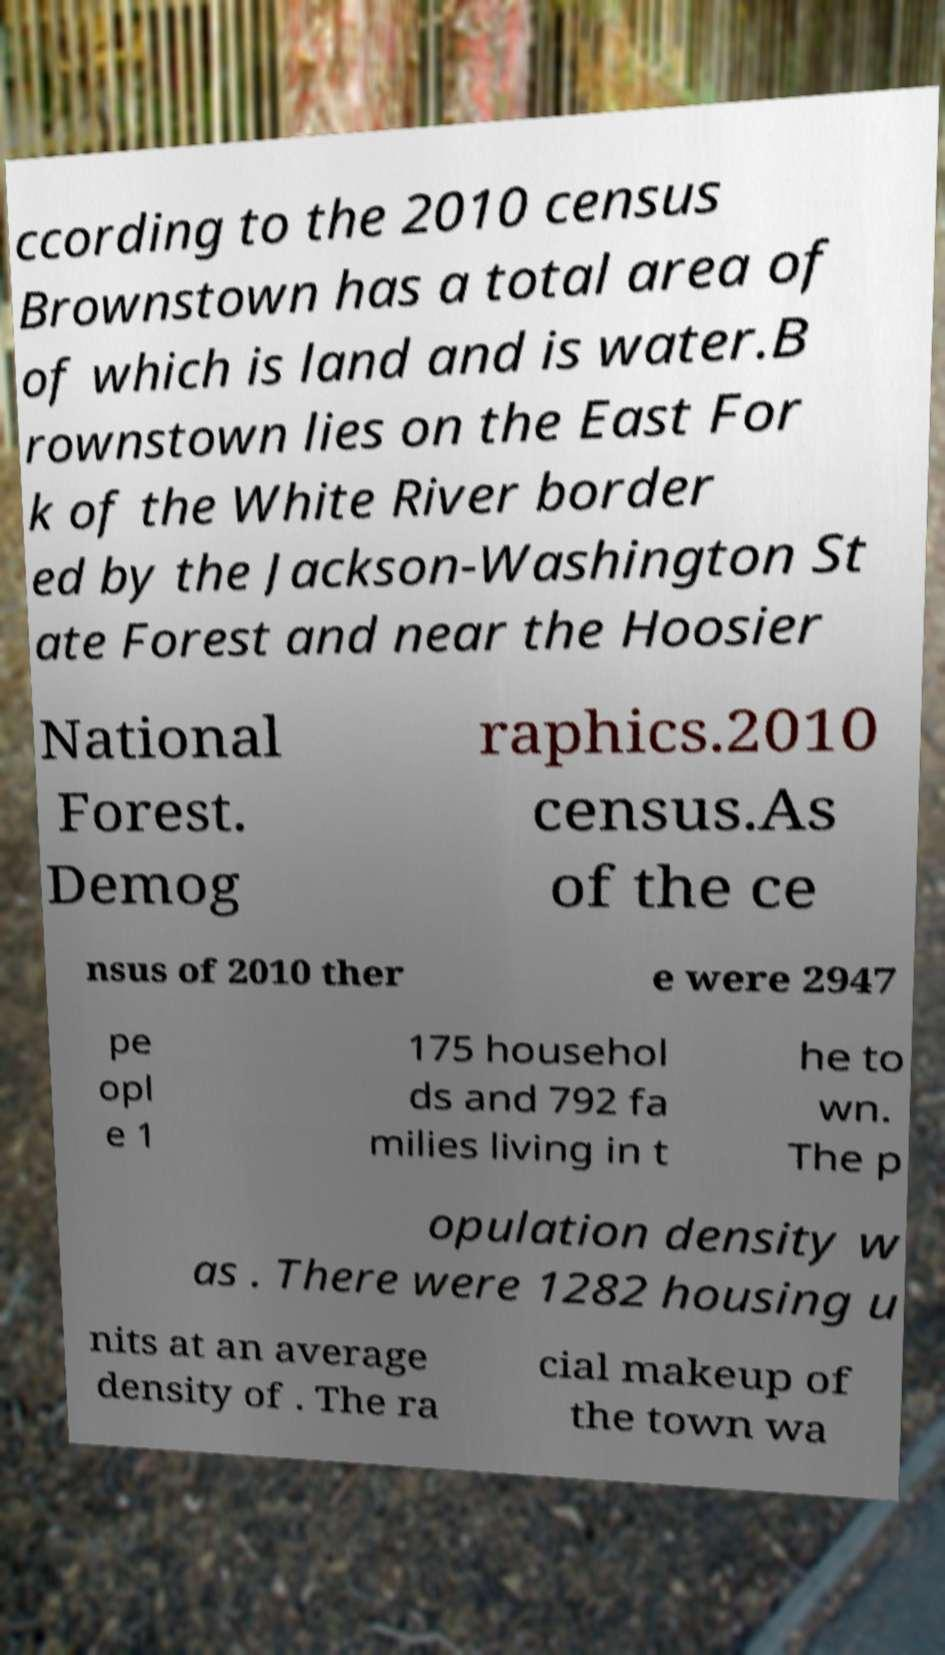Can you accurately transcribe the text from the provided image for me? ccording to the 2010 census Brownstown has a total area of of which is land and is water.B rownstown lies on the East For k of the White River border ed by the Jackson-Washington St ate Forest and near the Hoosier National Forest. Demog raphics.2010 census.As of the ce nsus of 2010 ther e were 2947 pe opl e 1 175 househol ds and 792 fa milies living in t he to wn. The p opulation density w as . There were 1282 housing u nits at an average density of . The ra cial makeup of the town wa 